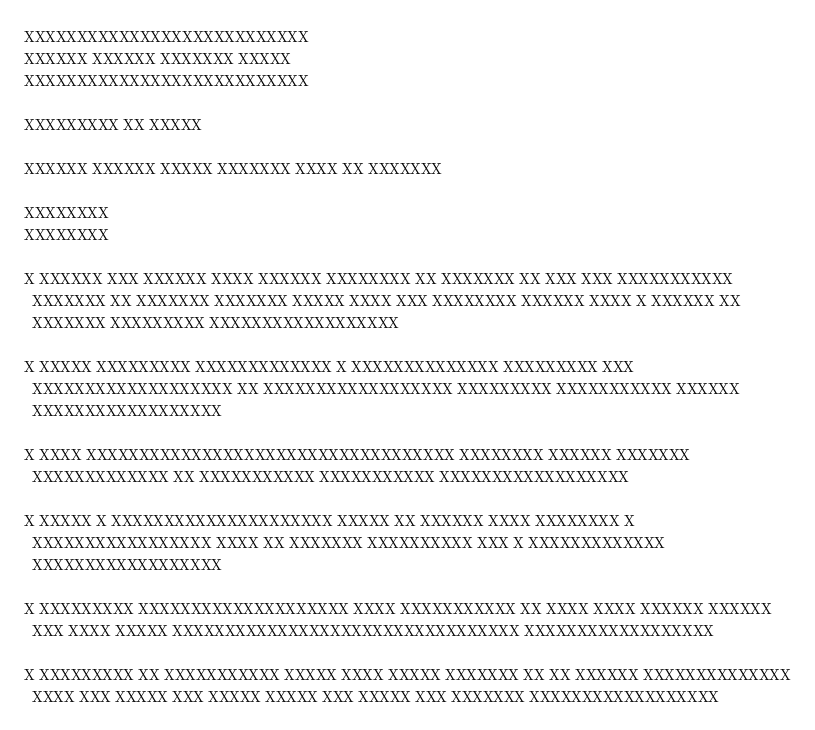Convert code to text. <code><loc_0><loc_0><loc_500><loc_500><_Python_>XXXXXXXXXXXXXXXXXXXXXXXXXXX
XXXXXX XXXXXX XXXXXXX XXXXX
XXXXXXXXXXXXXXXXXXXXXXXXXXX

XXXXXXXXX XX XXXXX

XXXXXX XXXXXX XXXXX XXXXXXX XXXX XX XXXXXXX

XXXXXXXX
XXXXXXXX

X XXXXXX XXX XXXXXX XXXX XXXXXX XXXXXXXX XX XXXXXXX XX XXX XXX XXXXXXXXXXX
  XXXXXXX XX XXXXXXX XXXXXXX XXXXX XXXX XXX XXXXXXXX XXXXXX XXXX X XXXXXX XX
  XXXXXXX XXXXXXXXX XXXXXXXXXXXXXXXXXX

X XXXXX XXXXXXXXX XXXXXXXXXXXXX X XXXXXXXXXXXXXX XXXXXXXXX XXX
  XXXXXXXXXXXXXXXXXXX XX XXXXXXXXXXXXXXXXXX XXXXXXXXX XXXXXXXXXXX XXXXXX
  XXXXXXXXXXXXXXXXXX

X XXXX XXXXXXXXXXXXXXXXXXXXXXXXXXXXXXXXXXX XXXXXXXX XXXXXX XXXXXXX
  XXXXXXXXXXXXX XX XXXXXXXXXXX XXXXXXXXXXX XXXXXXXXXXXXXXXXXX

X XXXXX X XXXXXXXXXXXXXXXXXXXXX XXXXX XX XXXXXX XXXX XXXXXXXX X
  XXXXXXXXXXXXXXXXX XXXX XX XXXXXXX XXXXXXXXXX XXX X XXXXXXXXXXXXX
  XXXXXXXXXXXXXXXXXX

X XXXXXXXXX XXXXXXXXXXXXXXXXXXXX XXXX XXXXXXXXXXX XX XXXX XXXX XXXXXX XXXXXX
  XXX XXXX XXXXX XXXXXXXXXXXXXXXXXXXXXXXXXXXXXXXXX XXXXXXXXXXXXXXXXXX

X XXXXXXXXX XX XXXXXXXXXXX XXXXX XXXX XXXXX XXXXXXX XX XX XXXXXX XXXXXXXXXXXXXX
  XXXX XXX XXXXX XXX XXXXX XXXXX XXX XXXXX XXX XXXXXXX XXXXXXXXXXXXXXXXXX
</code> 